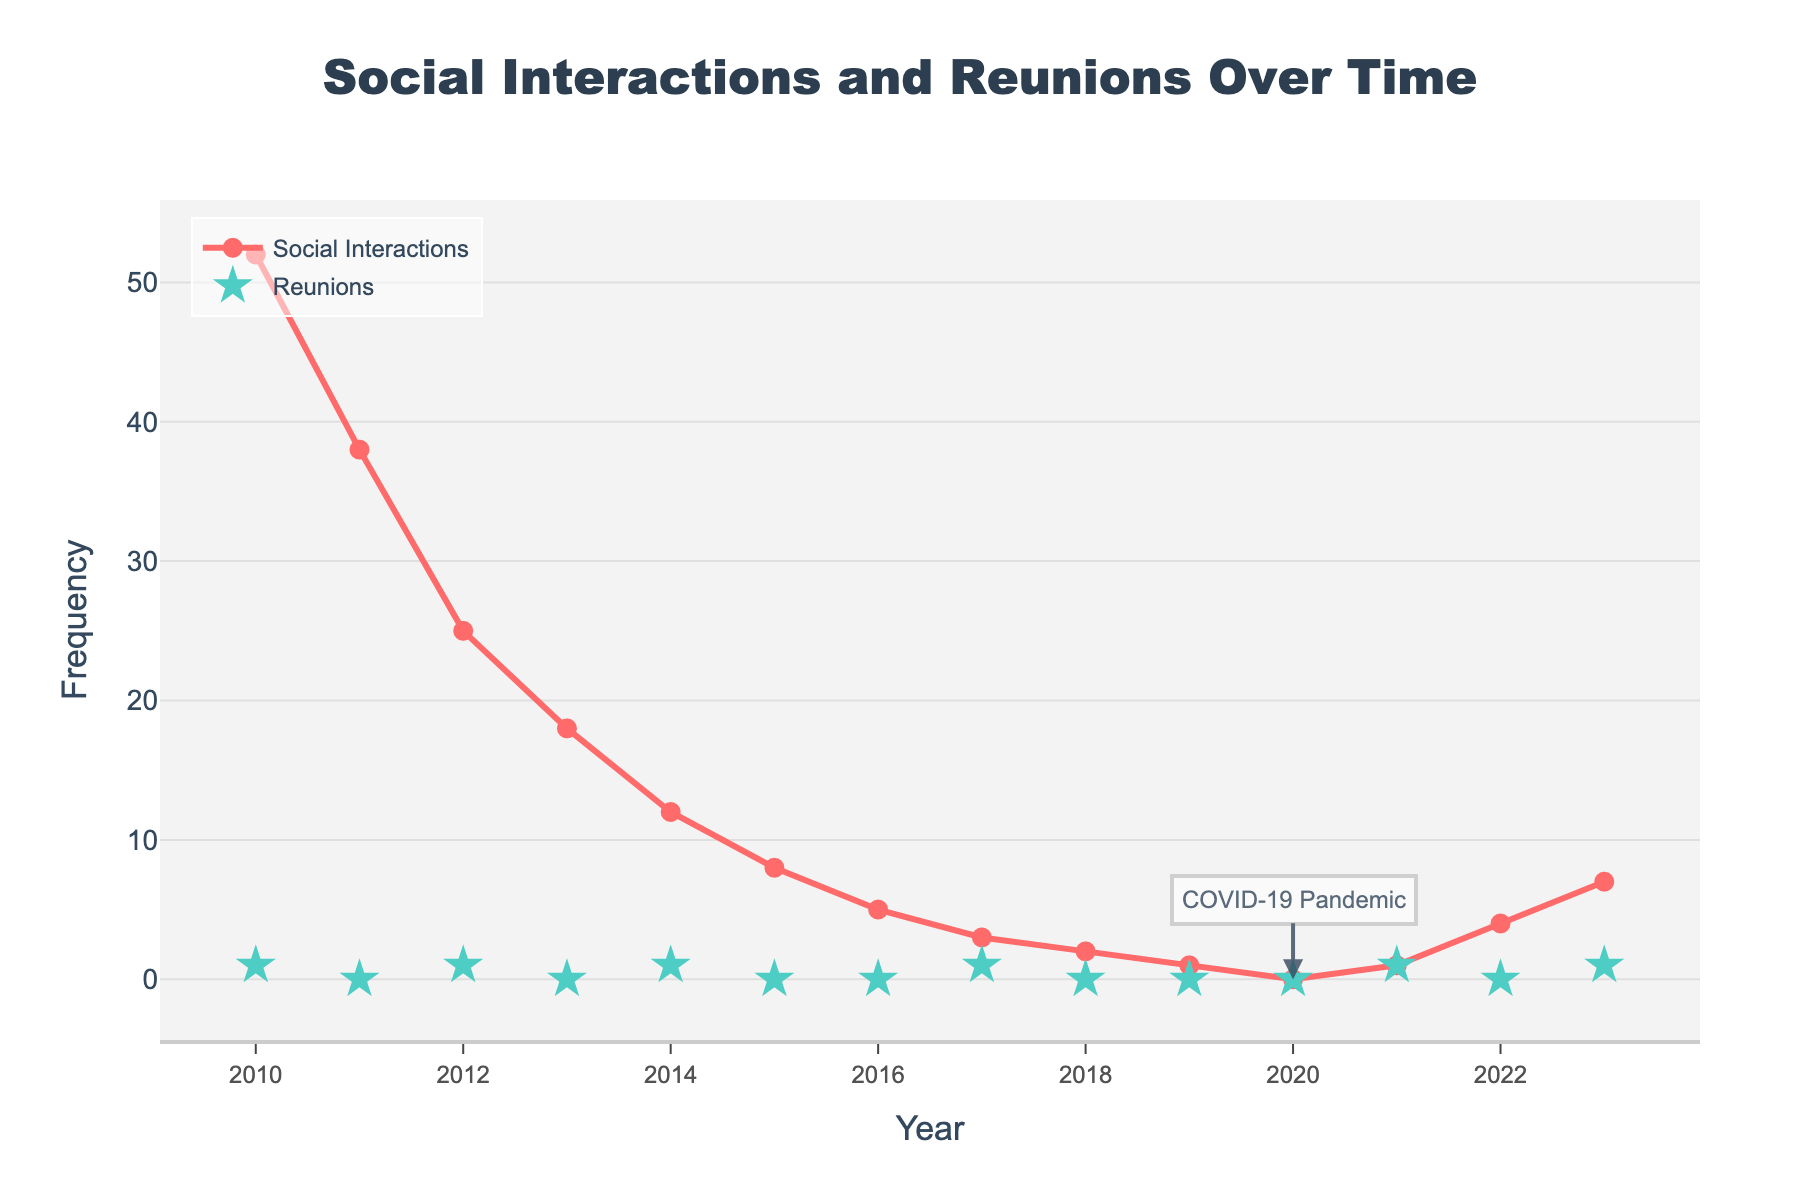How many total reunions were there from 2010 to 2023? Sum the values for 'Reunions' from 2010 to 2023: 1 + 0 + 1 + 0 + 1 + 0 + 0 + 1 + 0 + 0 + 0 + 1 + 0 + 1 = 6
Answer: 6 In which year did social interactions drop to their lowest point? From the figure, the 'Social Interactions' hit its lowest point in 2020 with a value of 0.
Answer: 2020 How did the number of social interactions in 2023 compare to those in 2010? In 2010, there were 52 social interactions, and in 2023, there were 7, showing a decrease of 45 interactions.
Answer: 7 interactions in 2023, down from 52 in 2010 What is the trend of social interactions over the years? The trend shows a general decline in social interactions from 2010 to 2020, with a slight increase after 2020.
Answer: Declining trend with a slight increase post-2020 How many more social interactions were there in 2011 compared to 2020? 2011 had 38 social interactions, and 2020 had 0; therefore, there were 38 more social interactions in 2011.
Answer: 38 Which year marked a reunion and also had the least social interactions among those years? Look for the least social interactions in the years with reunions. 2017 had a reunion and only 3 social interactions.
Answer: 2017 What happened in 2020 that might explain the trend in social interactions? The annotation on the chart mentions the COVID-19 pandemic occurring in 2020, which likely caused a drop to 0 social interactions.
Answer: COVID-19 pandemic Between 2012 and 2015, what is the average number of social interactions per year? Sum the social interactions from 2012 to 2015: 25 + 18 + 12 + 8 = 63. There are 4 years, so the average is 63 / 4 = 15.75.
Answer: 15.75 Which has a sharper decline: social interactions from 2010 to 2011 or from 2011 to 2012? Calculate the drop: 2010 to 2011: 52 - 38 = 14, and 2011 to 2012: 38 - 25 = 13. The sharper decline is from 2010 to 2011.
Answer: 2010 to 2011 How did social interactions change between 2020 and 2023? From 2020 to 2023, social interactions increased from 0 to 7.
Answer: Increased from 0 to 7 